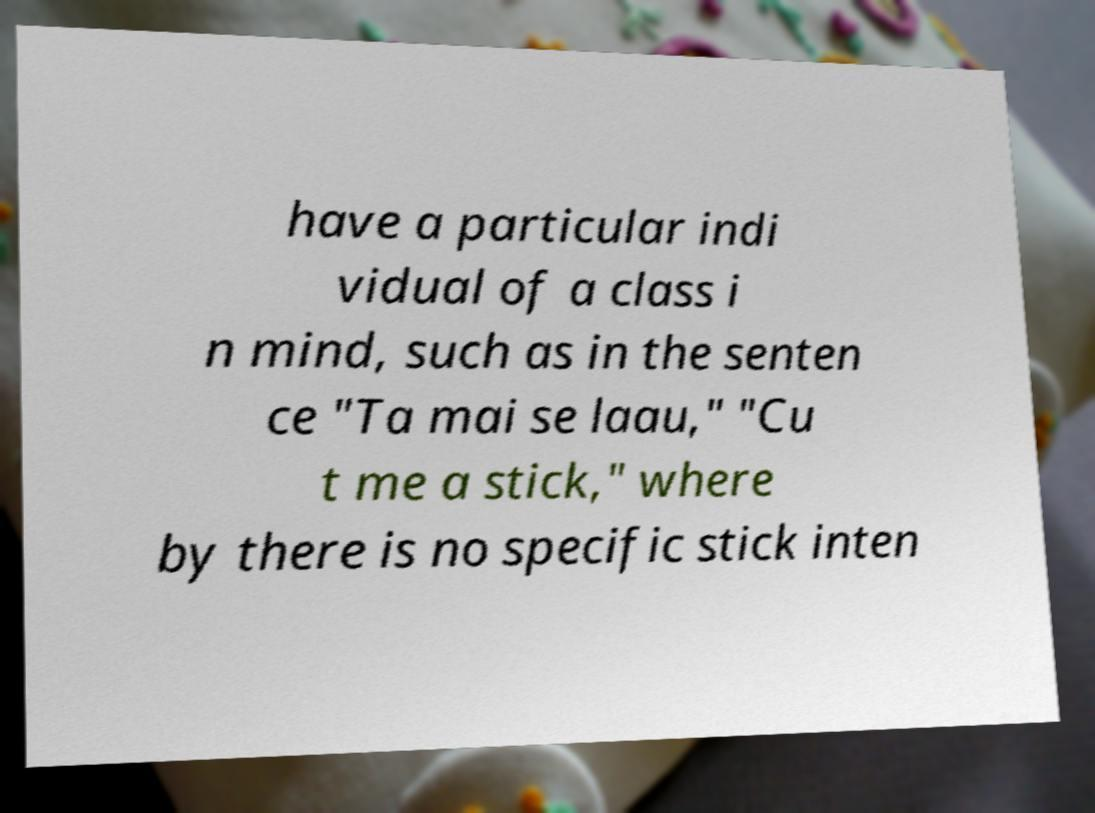Can you read and provide the text displayed in the image?This photo seems to have some interesting text. Can you extract and type it out for me? have a particular indi vidual of a class i n mind, such as in the senten ce "Ta mai se laau," "Cu t me a stick," where by there is no specific stick inten 